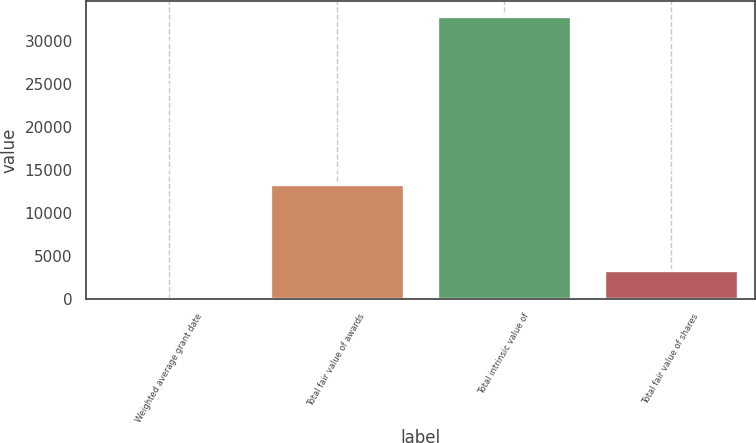<chart> <loc_0><loc_0><loc_500><loc_500><bar_chart><fcel>Weighted average grant date<fcel>Total fair value of awards<fcel>Total intrinsic value of<fcel>Total fair value of shares<nl><fcel>9.51<fcel>13388<fcel>32940<fcel>3302.56<nl></chart> 